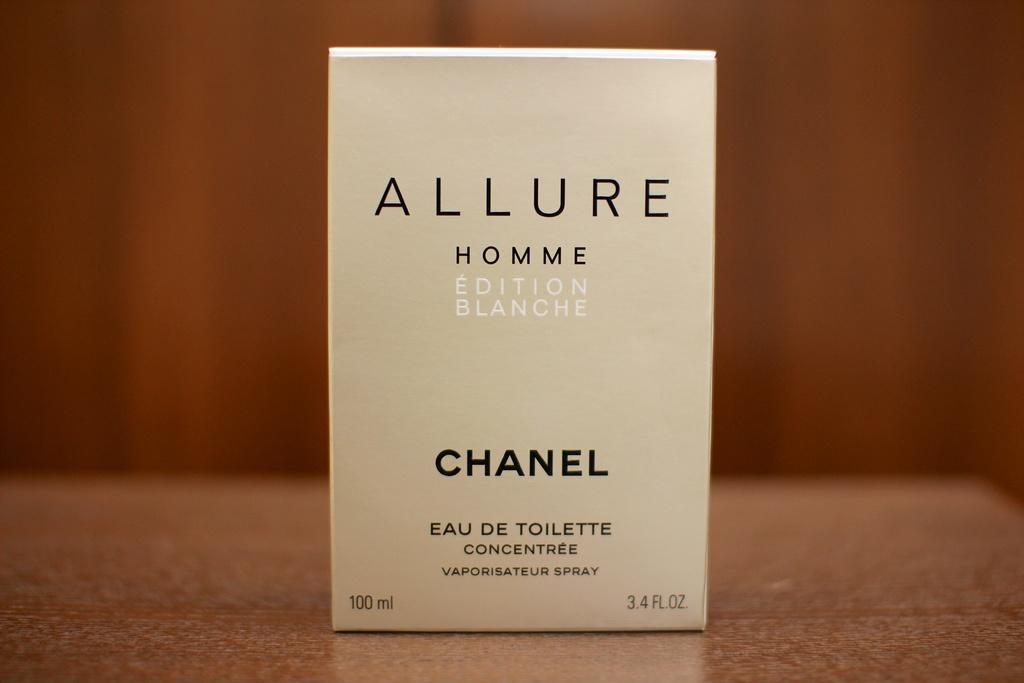Can you describe this image briefly? In this image I can see a white color box on the table, on the box I can see something written on it and the table is in brown color. 